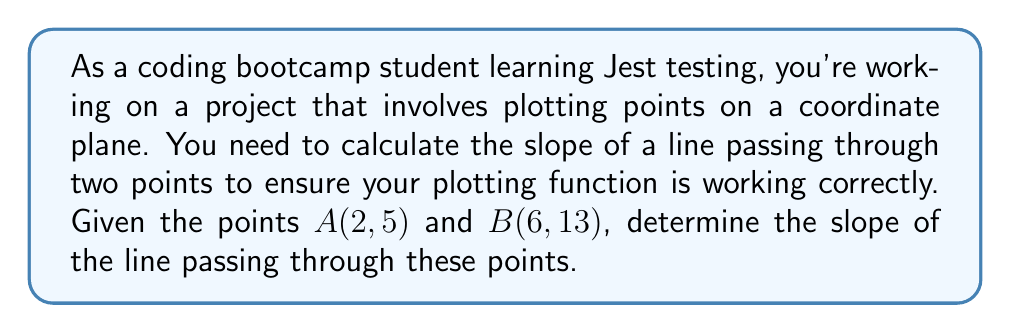Could you help me with this problem? To calculate the slope of a line given two points, we use the slope formula:

$$ m = \frac{y_2 - y_1}{x_2 - x_1} $$

Where $(x_1, y_1)$ and $(x_2, y_2)$ are the coordinates of two points on the line.

For our given points:
$A(2, 5)$: $x_1 = 2$, $y_1 = 5$
$B(6, 13)$: $x_2 = 6$, $y_2 = 13$

Let's substitute these values into the slope formula:

$$ m = \frac{13 - 5}{6 - 2} $$

Simplify:
$$ m = \frac{8}{4} $$

Reduce the fraction:
$$ m = 2 $$

Therefore, the slope of the line passing through points $A(2, 5)$ and $B(6, 13)$ is 2.

In your Jest test, you could use this result to verify that your slope calculation function returns the correct value for these input points.
Answer: $m = 2$ 